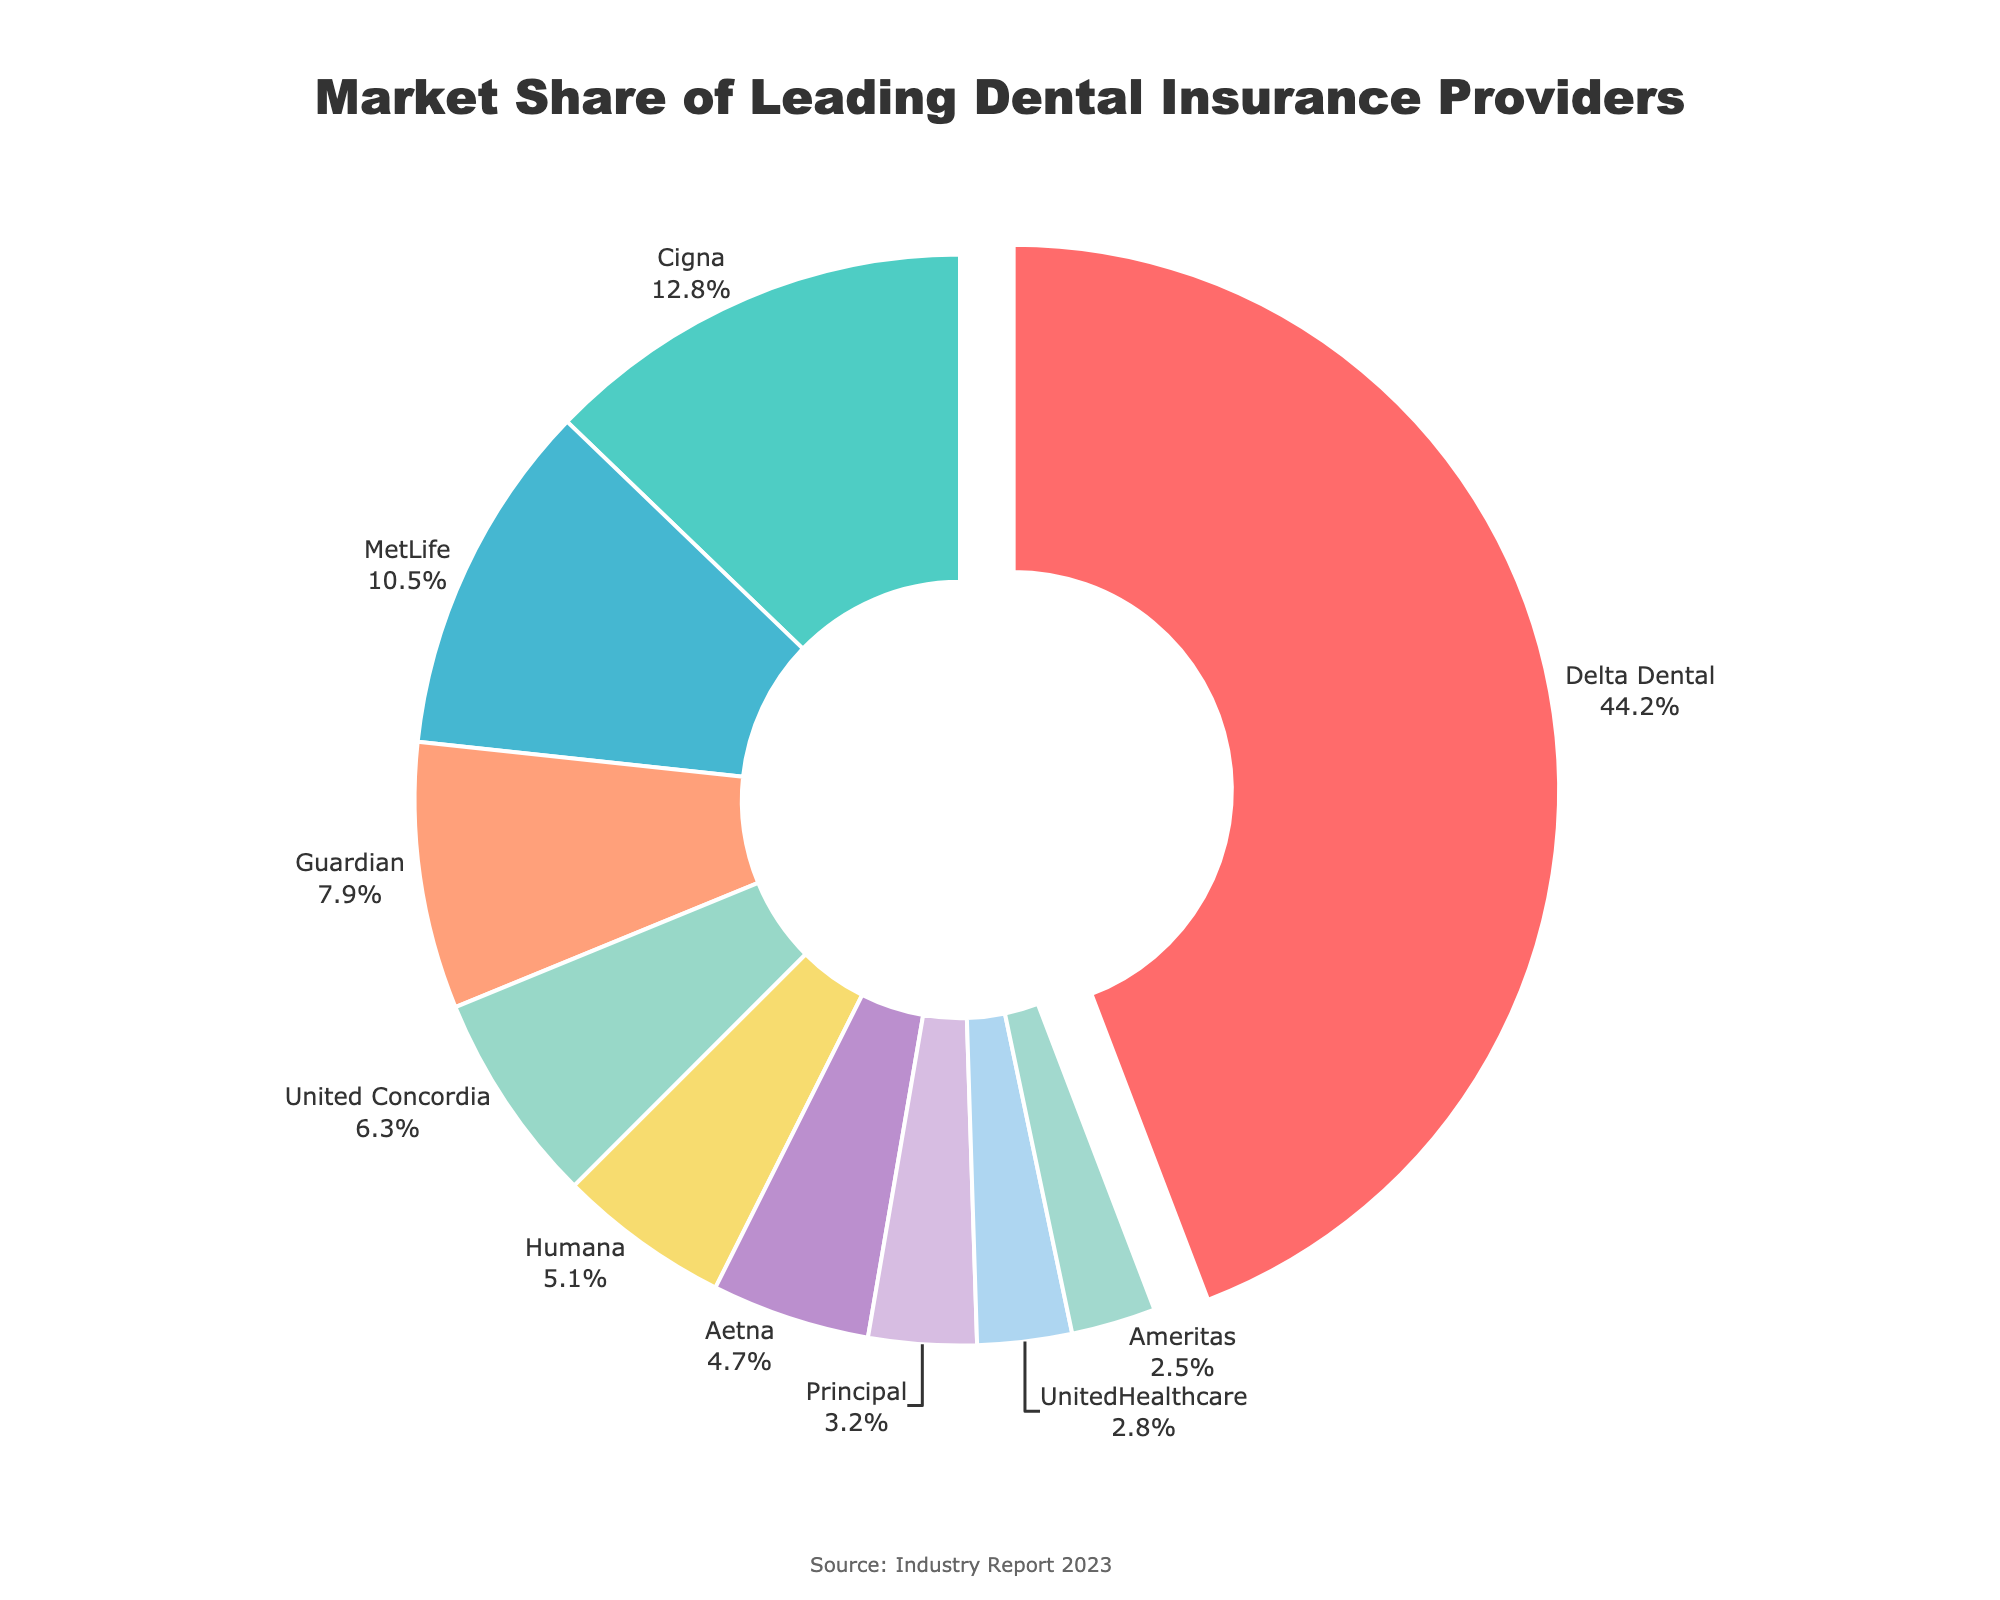What is the market share of the company with the largest share? The pie chart highlights the sector for the company with the largest market share, which is Delta Dental. As indicated, Delta Dental has a market share of 44.2%.
Answer: 44.2% Which company has the second-largest market share, and what is their percentage? The pie chart shows different market shares by segment size and labels. The second-largest market share is held by Cigna, with 12.8%.
Answer: Cigna, 12.8% How much more market share does Delta Dental have than United Concordia? The market share of Delta Dental is 44.2%, and that of United Concordia is 6.3%. Subtracting these gives 44.2% - 6.3% = 37.9%.
Answer: 37.9% What is the combined market share of MetLife and Guardian? Looking at the pie chart, MetLife has 10.5% and Guardian has 7.9%. Summing these values gives 10.5% + 7.9% = 18.4%.
Answer: 18.4% Which company has the smallest market share, and what is the percentage? The pie chart segments show various market shares, with Ameritas having the smallest share at 2.5%.
Answer: Ameritas, 2.5% If you combine the market shares of the top three companies, what is the total percentage? Delta Dental (44.2%), Cigna (12.8%), and MetLife (10.5%) are the top three companies. Adding their shares gives 44.2% + 12.8% + 10.5% = 67.5%.
Answer: 67.5% Which companies have a market share greater than 10%? Observing the pie chart, the companies with more than 10% market share are Delta Dental (44.2%), Cigna (12.8%), and MetLife (10.5%).
Answer: Delta Dental, Cigna, MetLife What is the difference in market share between Humana and Aetna? According to the pie chart, Humana has a market share of 5.1% and Aetna has 4.7%. The difference is calculated as 5.1% - 4.7% = 0.4%.
Answer: 0.4% Identify the company represented by the green segment and provide their market share percentage. The green segment in the pie chart represents Cigna, which has a market share of 12.8%.
Answer: Cigna, 12.8% What is the sum of the market shares of UnitedHealthcare and Ameritas? The market shares of UnitedHealthcare and Ameritas are 2.8% and 2.5%, respectively. Summing these gives 2.8% + 2.5% = 5.3%.
Answer: 5.3% 